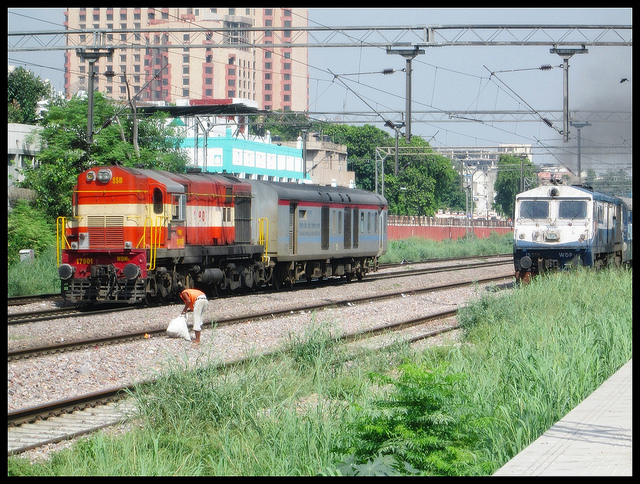<image>What train car has been left behind here? I don't know which train car has been left behind here. It could be an engine car or a white car. What train car has been left behind here? I am not sure what train car has been left behind here. It can be seen engine car, trash, white car or white with blue color train. 